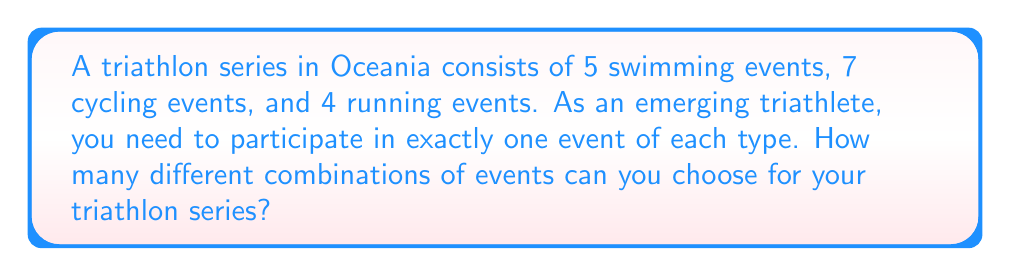What is the answer to this math problem? To solve this problem, we need to use the multiplication principle of counting. This principle states that if we have a sequence of independent choices, where there are $n_1$ ways of making the first choice, $n_2$ ways of making the second choice, and so on up to $n_k$ ways of making the $k$-th choice, then the total number of ways to make all these choices is the product $n_1 \times n_2 \times ... \times n_k$.

In this case, we have three independent choices:

1. Choosing a swimming event: There are 5 options
2. Choosing a cycling event: There are 7 options
3. Choosing a running event: There are 4 options

Each of these choices is independent of the others, meaning that your choice for one event doesn't affect your options for the other events.

Therefore, the total number of possible combinations is:

$$5 \times 7 \times 4 = 140$$

This means that for each of the 5 swimming events, you have 7 choices for cycling, and for each of those combinations, you have 4 choices for running, resulting in a total of 140 different possible combinations.
Answer: 140 possible combinations 